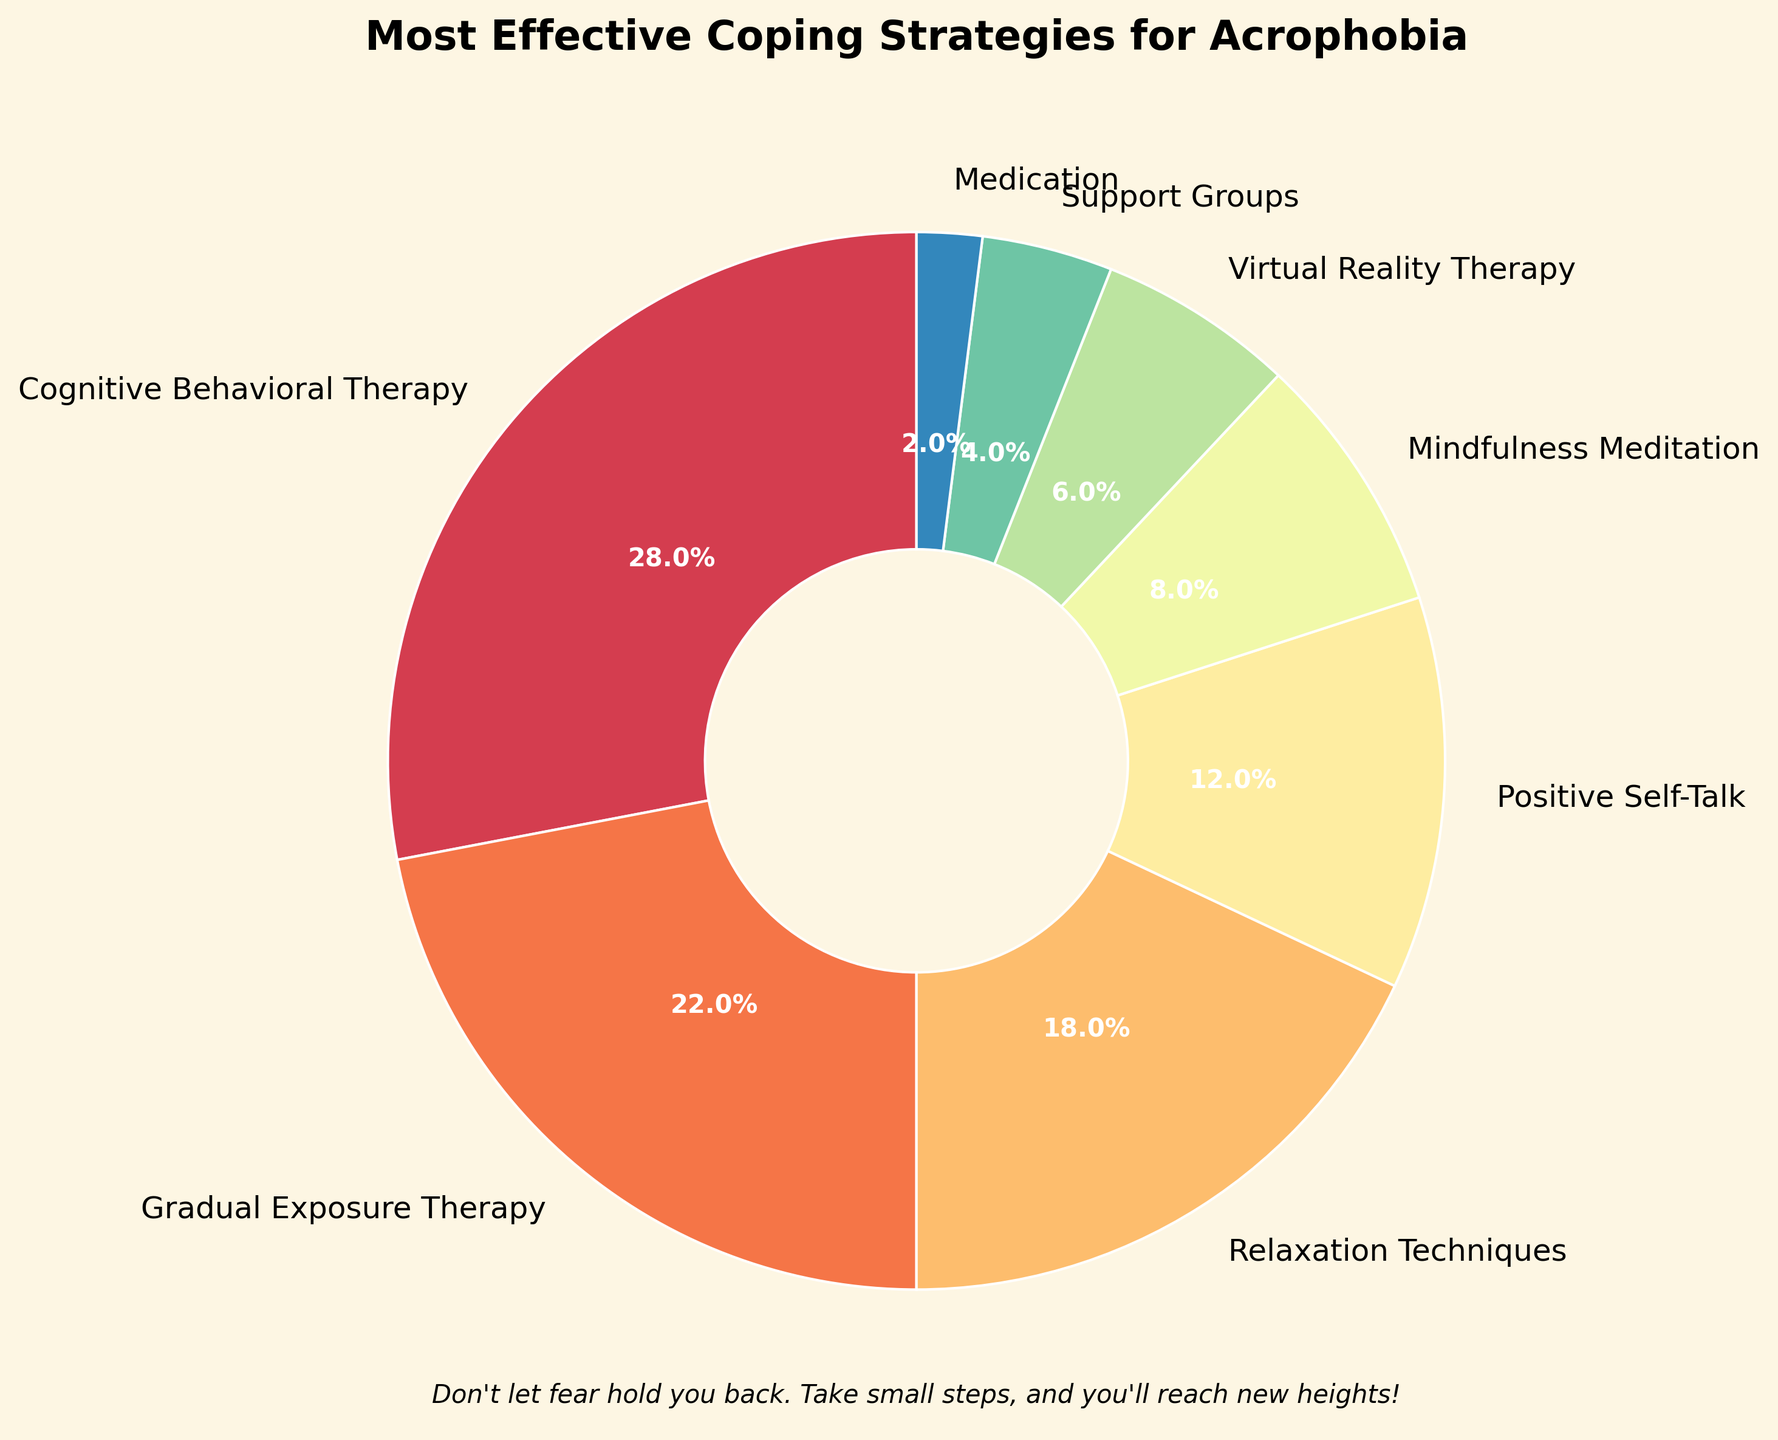what is the largest coping strategy by percentage? The largest segment in the pie chart is labeled "Cognitive Behavioral Therapy," with an autopct showing 28%.
Answer: Cognitive Behavioral Therapy which coping strategy has the second largest percentage after Cognitive Behavioral Therapy? By looking at the pie chart, after Cognitive Behavioral Therapy at 28%, the next largest segment is labeled "Gradual Exposure Therapy," which is 22%.
Answer: Gradual Exposure Therapy how much more effective is Positive Self-Talk compared to Virtual Reality Therapy? Positive Self-Talk accounts for 12% while Virtual Reality Therapy is at 6%. The difference between them is 12% - 6% = 6%.
Answer: 6% What percentage of people use Mindfulness Meditation and Support Groups combined? The pie chart shows Mindfulness Meditation at 8% and Support Groups at 4%. Adding them together gives 8% + 4% = 12%.
Answer: 12% which coping strategy has the least percentage? The smallest segment in the pie chart is labeled "Medication" with 2%.
Answer: Medication what is the combined percentage of the top three coping strategies? The top three coping strategies are Cognitive Behavioral Therapy (28%), Gradual Exposure Therapy (22%), and Relaxation Techniques (18%). The combined percentage is 28% + 22% + 18% = 68%.
Answer: 68% how does Medication compare to Support Groups in terms of percentage? The pie chart shows Medication at 2% while Support Groups are at 4%. Therefore, Medication is half of Support Groups.
Answer: Medication is half of Support Groups which coping strategies occupy approximately one-quarter of the pie chart when combined? Relaxation Techniques at 18% and Positive Self-Talk at 12% together make up 18% + 12% = 30%, which is approximately one-quarter of the pie chart.
Answer: Relaxation Techniques and Positive Self-Talk how many coping strategies occupy less than 10% each? From the pie chart, the coping strategies that occupy less than 10% each are Positive Self-Talk (12% - excluded), Mindfulness Meditation (8%), Virtual Reality Therapy (6%), Support Groups (4%), and Medication (2%) - making it 4 strategies
Answer: 4 